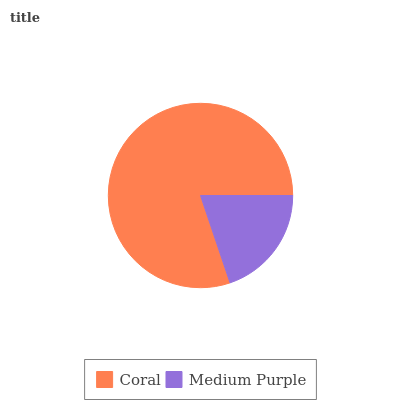Is Medium Purple the minimum?
Answer yes or no. Yes. Is Coral the maximum?
Answer yes or no. Yes. Is Medium Purple the maximum?
Answer yes or no. No. Is Coral greater than Medium Purple?
Answer yes or no. Yes. Is Medium Purple less than Coral?
Answer yes or no. Yes. Is Medium Purple greater than Coral?
Answer yes or no. No. Is Coral less than Medium Purple?
Answer yes or no. No. Is Coral the high median?
Answer yes or no. Yes. Is Medium Purple the low median?
Answer yes or no. Yes. Is Medium Purple the high median?
Answer yes or no. No. Is Coral the low median?
Answer yes or no. No. 